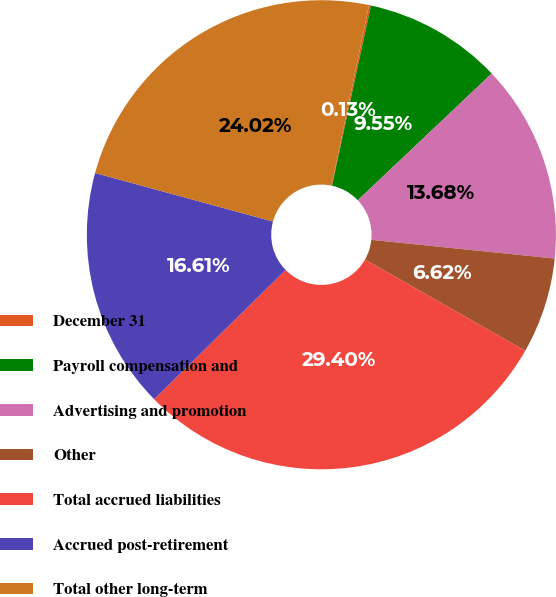Convert chart to OTSL. <chart><loc_0><loc_0><loc_500><loc_500><pie_chart><fcel>December 31<fcel>Payroll compensation and<fcel>Advertising and promotion<fcel>Other<fcel>Total accrued liabilities<fcel>Accrued post-retirement<fcel>Total other long-term<nl><fcel>0.13%<fcel>9.55%<fcel>13.68%<fcel>6.62%<fcel>29.4%<fcel>16.61%<fcel>24.02%<nl></chart> 